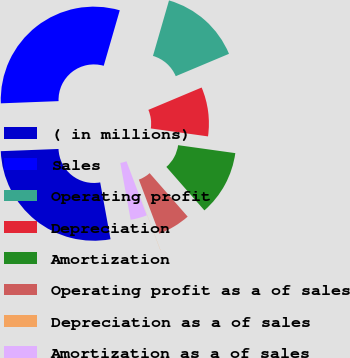Convert chart to OTSL. <chart><loc_0><loc_0><loc_500><loc_500><pie_chart><fcel>( in millions)<fcel>Sales<fcel>Operating profit<fcel>Depreciation<fcel>Amortization<fcel>Operating profit as a of sales<fcel>Depreciation as a of sales<fcel>Amortization as a of sales<nl><fcel>27.26%<fcel>30.09%<fcel>14.19%<fcel>8.53%<fcel>11.36%<fcel>5.69%<fcel>0.02%<fcel>2.86%<nl></chart> 